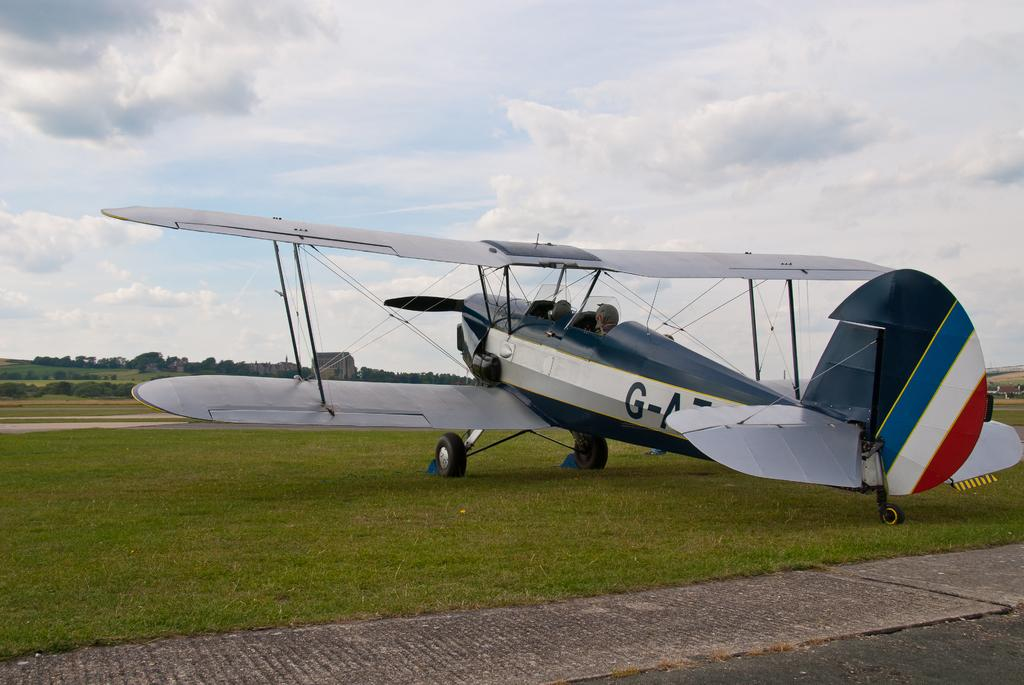What is the main subject of the image? The main subject of the image is an aeroplane. What colors are used to paint the aeroplane? The aeroplane is in white, blue, and red colors. What feature of the aeroplane can be seen in the image? There are wheels visible on the aeroplane. What can be seen in the background of the image? There are trees in the background of the image. What colors are used to depict the sky in the image? The sky is in white and blue colors. Where is the stream located in the image? There is no stream present in the image. What type of egg can be seen in the image? There are no eggs present in the image. 